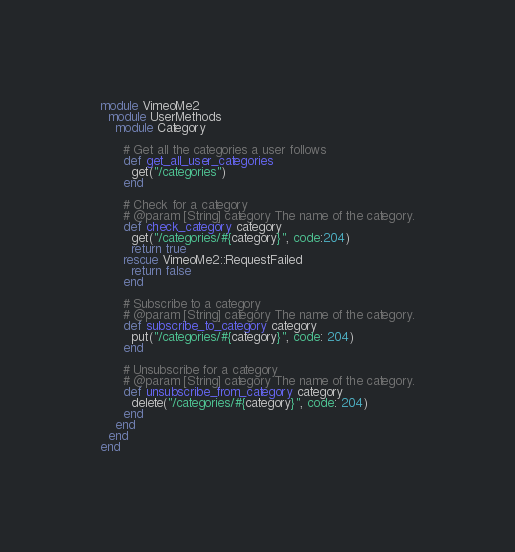<code> <loc_0><loc_0><loc_500><loc_500><_Ruby_>module VimeoMe2
  module UserMethods
    module Category

      # Get all the categories a user follows
      def get_all_user_categories
        get("/categories")
      end

      # Check for a category
      # @param [String] category The name of the category.
      def check_category category
        get("/categories/#{category}", code:204)
        return true
      rescue VimeoMe2::RequestFailed
        return false
      end

      # Subscribe to a category
      # @param [String] category The name of the category.
      def subscribe_to_category category
        put("/categories/#{category}", code: 204)
      end

      # Unsubscribe for a category
      # @param [String] category The name of the category.
      def unsubscribe_from_category category
        delete("/categories/#{category}", code: 204)
      end
    end
  end
end
</code> 